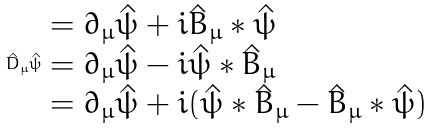Convert formula to latex. <formula><loc_0><loc_0><loc_500><loc_500>\hat { D } _ { \mu } \hat { \psi } \begin{array} [ t ] { l } = \partial _ { \mu } \hat { \psi } + i \hat { B } _ { \mu } * \hat { \psi } \\ = \partial _ { \mu } \hat { \psi } - i \hat { \psi } * \hat { B } _ { \mu } \\ = \partial _ { \mu } \hat { \psi } + i ( \hat { \psi } * \hat { B } _ { \mu } - \hat { B } _ { \mu } * \hat { \psi } ) \end{array}</formula> 